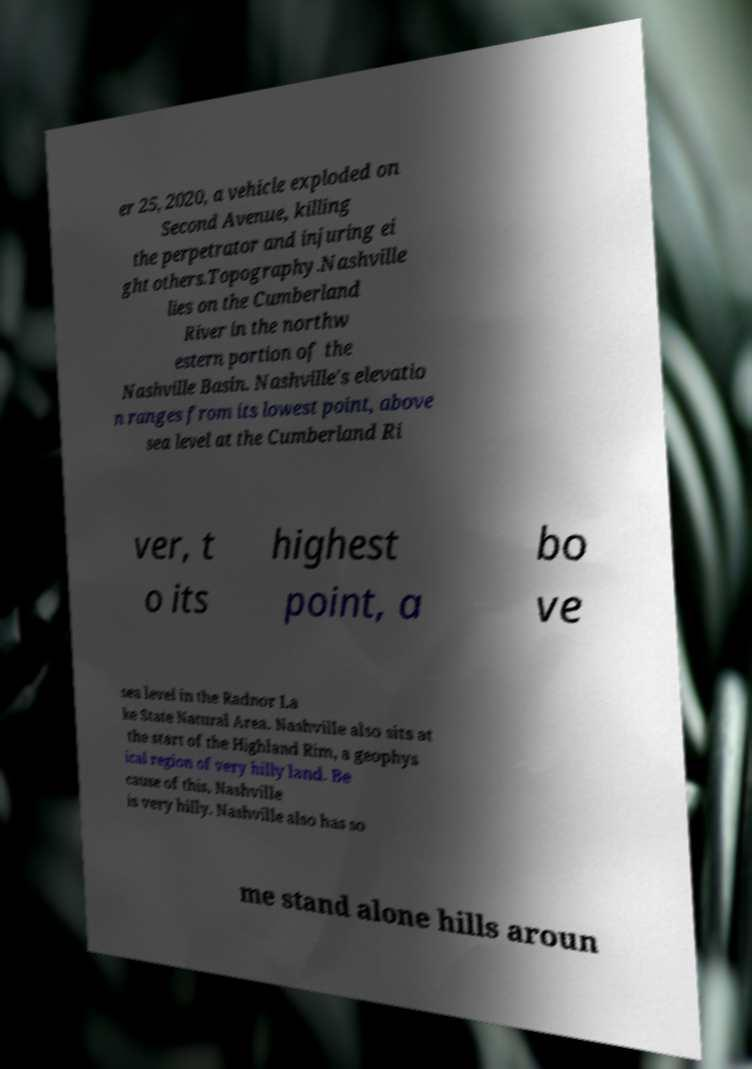For documentation purposes, I need the text within this image transcribed. Could you provide that? er 25, 2020, a vehicle exploded on Second Avenue, killing the perpetrator and injuring ei ght others.Topography.Nashville lies on the Cumberland River in the northw estern portion of the Nashville Basin. Nashville's elevatio n ranges from its lowest point, above sea level at the Cumberland Ri ver, t o its highest point, a bo ve sea level in the Radnor La ke State Natural Area. Nashville also sits at the start of the Highland Rim, a geophys ical region of very hilly land. Be cause of this, Nashville is very hilly. Nashville also has so me stand alone hills aroun 